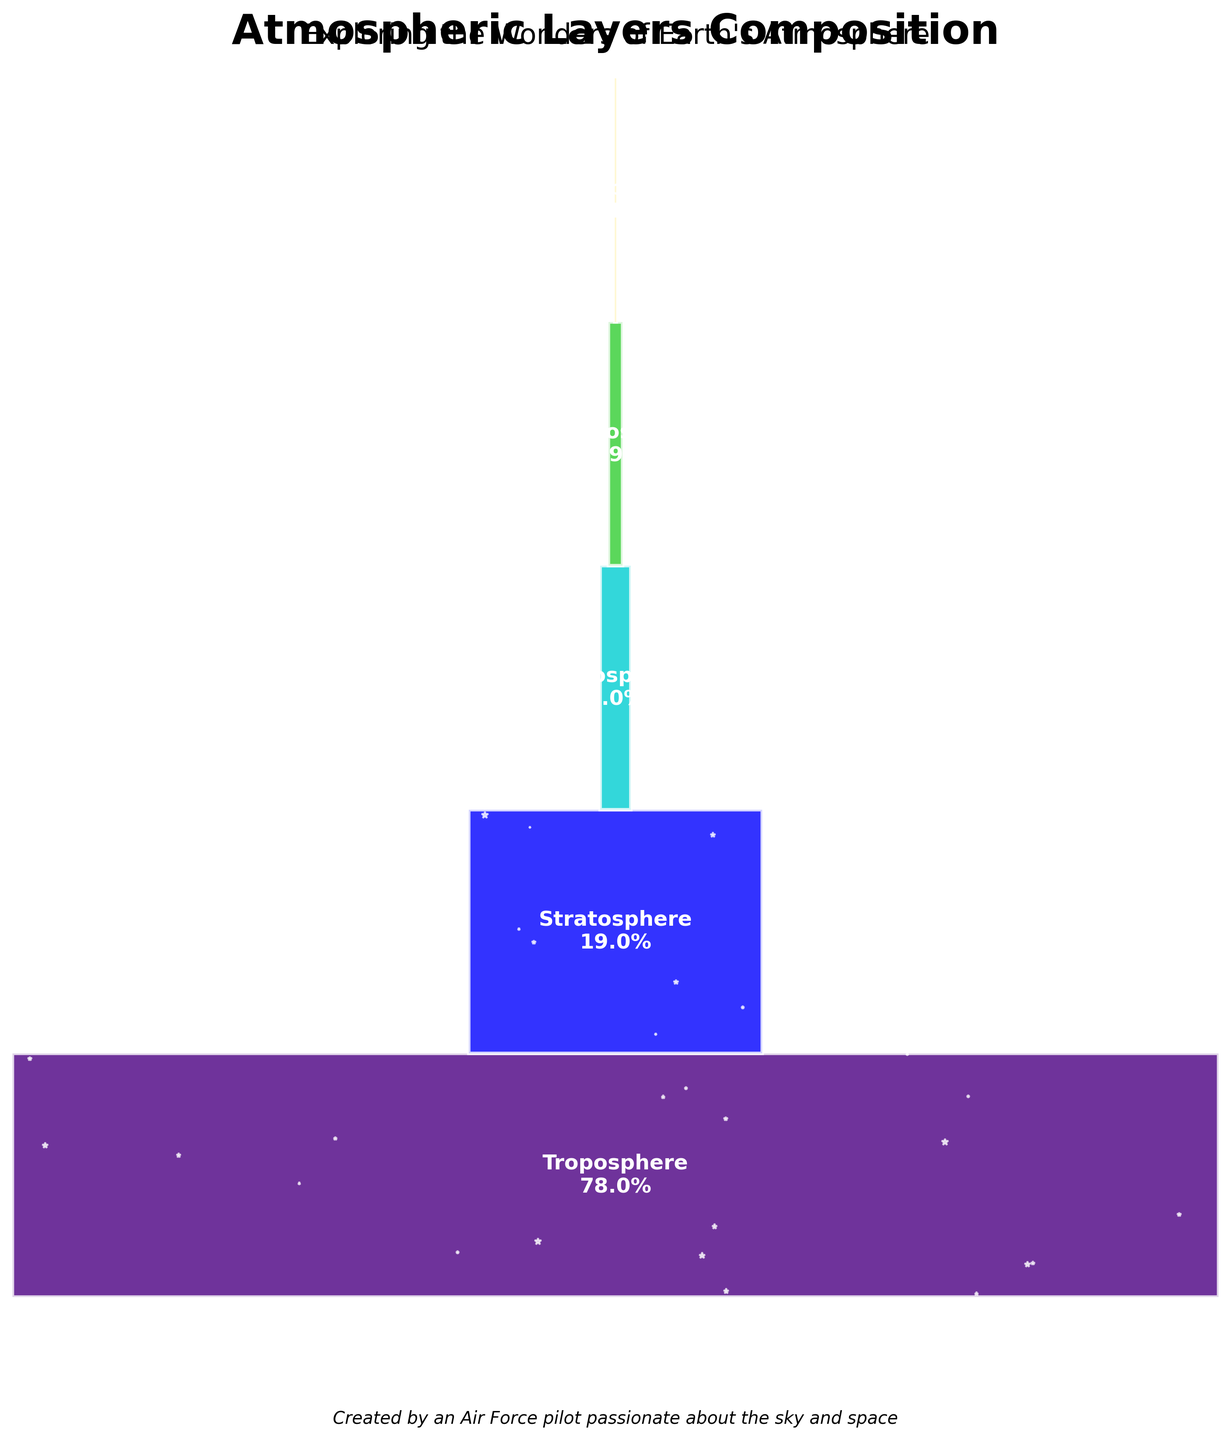What is the title of the figure? The title is located at the top of the figure in bold and larger font size, easily identifying it.
Answer: "Atmospheric Layers Composition" Which atmospheric layer has the highest composition percentage? By looking at the size and width of the bar, you can identify the largest bar representing the highest percentage.
Answer: Troposphere Which atmospheric layer has the lowest composition percentage? The smallest and thinnest bar represents the layer with the lowest percentage.
Answer: Exosphere What is the total percentage composition of the Troposphere and Stratosphere combined? Add the percentages for the Troposphere and Stratosphere: 78% (Troposphere) + 19% (Stratosphere).
Answer: 97% Which layers make up less than 1% of the atmosphere? Identify the bars that represent percentages below 1%. This involves comparing their sizes to others.
Answer: Thermosphere and Exosphere How do the percentages of the Mesosphere and Thermosphere compare? Compare the figures given for both layers: Mesosphere at 2% and Thermosphere at 0.9%.
Answer: Mesosphere is greater than Thermosphere How many layers are represented in the figure? Count the total number of distinct layers identified by their labels.
Answer: 5 Which layer covers more: Stratosphere or Mesosphere, and by how much? Subtract the percentage of the Mesosphere from the percentage of the Stratosphere: 19% (Stratosphere) - 2% (Mesosphere) = 17%.
Answer: Stratosphere covers 17% more What's the average percentage composition of all atmospheric layers? Sum all the percentages and divide by the number of layers: (78% + 19% + 2% + 0.9% + 0.1%) / 5 = 20%.
Answer: 20% If you were to visually describe the width of the bar representing the Thermosphere, how would it appear in comparison to the Troposphere? The width is relative to their percentages; Thermosphere at 0.9% is much narrower compared to the Troposphere at 78%.
Answer: Much narrower 